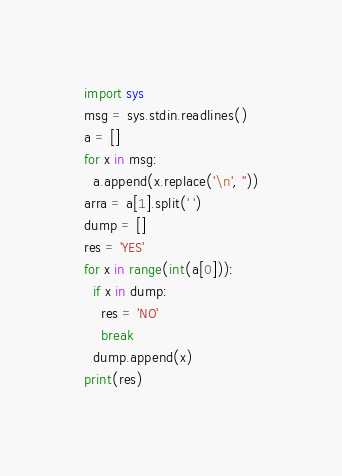<code> <loc_0><loc_0><loc_500><loc_500><_Python_>import sys
msg = sys.stdin.readlines()
a = []
for x in msg:
  a.append(x.replace('\n', ''))
arra = a[1].split(' ')
dump = []
res = 'YES'
for x in range(int(a[0])):
  if x in dump:
    res = 'NO'
    break
  dump.append(x)
print(res)

</code> 